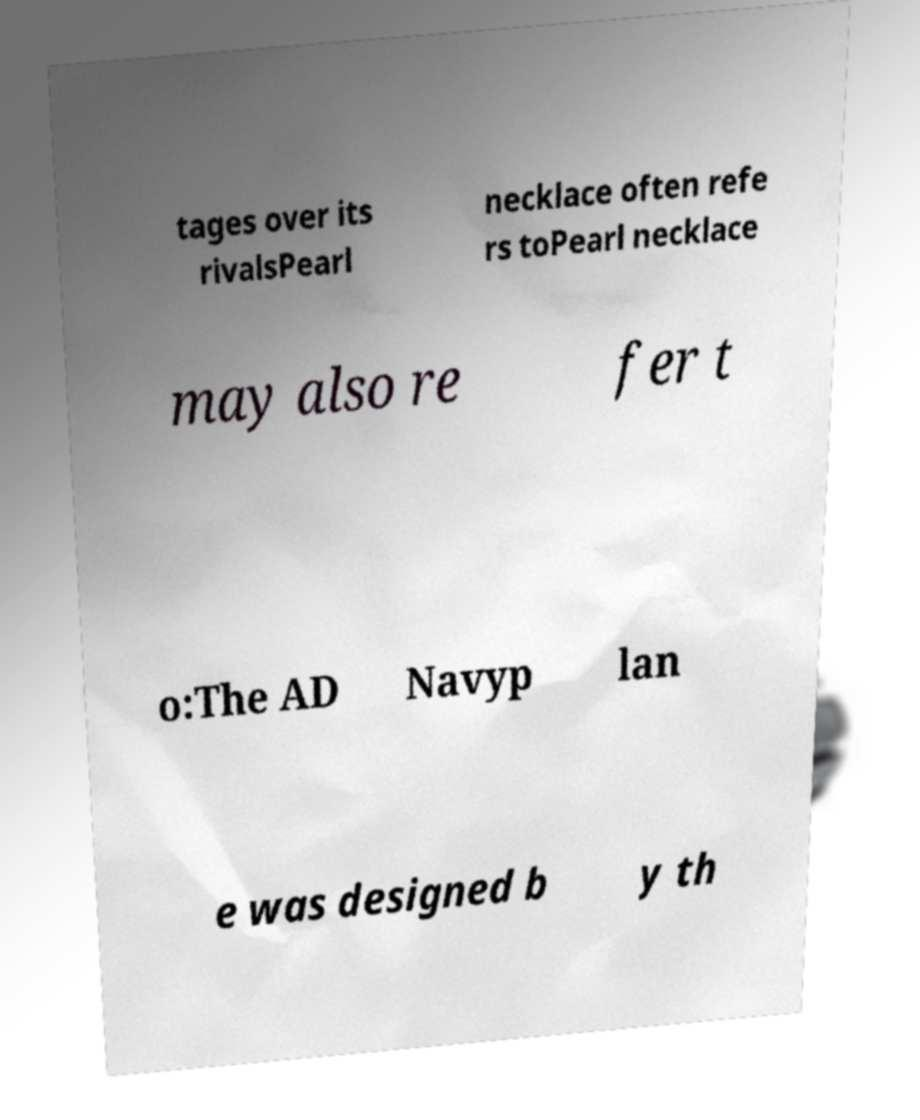Can you read and provide the text displayed in the image?This photo seems to have some interesting text. Can you extract and type it out for me? tages over its rivalsPearl necklace often refe rs toPearl necklace may also re fer t o:The AD Navyp lan e was designed b y th 